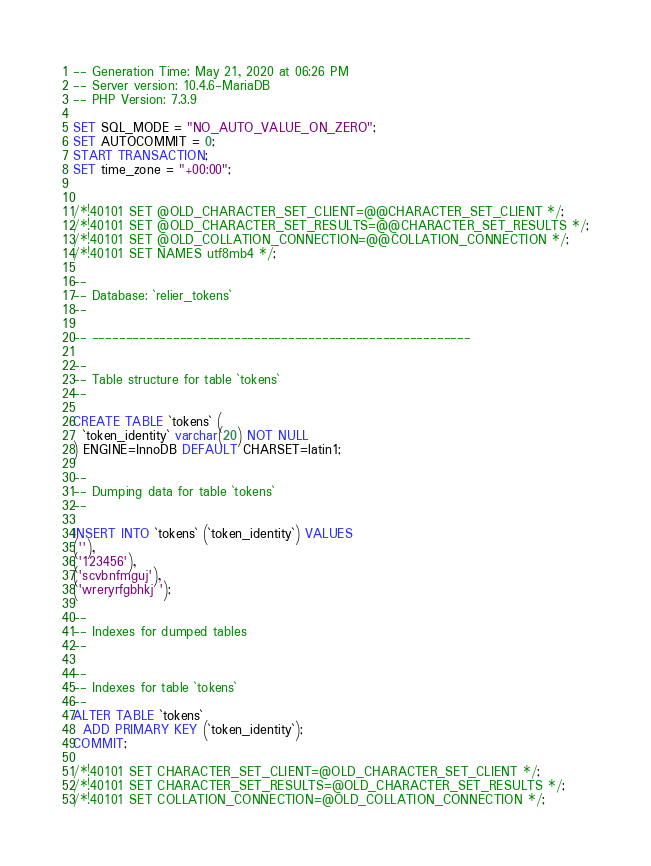<code> <loc_0><loc_0><loc_500><loc_500><_SQL_>-- Generation Time: May 21, 2020 at 06:26 PM
-- Server version: 10.4.6-MariaDB
-- PHP Version: 7.3.9

SET SQL_MODE = "NO_AUTO_VALUE_ON_ZERO";
SET AUTOCOMMIT = 0;
START TRANSACTION;
SET time_zone = "+00:00";


/*!40101 SET @OLD_CHARACTER_SET_CLIENT=@@CHARACTER_SET_CLIENT */;
/*!40101 SET @OLD_CHARACTER_SET_RESULTS=@@CHARACTER_SET_RESULTS */;
/*!40101 SET @OLD_COLLATION_CONNECTION=@@COLLATION_CONNECTION */;
/*!40101 SET NAMES utf8mb4 */;

--
-- Database: `relier_tokens`
--

-- --------------------------------------------------------

--
-- Table structure for table `tokens`
--

CREATE TABLE `tokens` (
  `token_identity` varchar(20) NOT NULL
) ENGINE=InnoDB DEFAULT CHARSET=latin1;

--
-- Dumping data for table `tokens`
--

INSERT INTO `tokens` (`token_identity`) VALUES
(''),
('123456'),
('scvbnfmguj'),
('wreryrfgbhkj ');

--
-- Indexes for dumped tables
--

--
-- Indexes for table `tokens`
--
ALTER TABLE `tokens`
  ADD PRIMARY KEY (`token_identity`);
COMMIT;

/*!40101 SET CHARACTER_SET_CLIENT=@OLD_CHARACTER_SET_CLIENT */;
/*!40101 SET CHARACTER_SET_RESULTS=@OLD_CHARACTER_SET_RESULTS */;
/*!40101 SET COLLATION_CONNECTION=@OLD_COLLATION_CONNECTION */;
</code> 